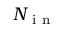Convert formula to latex. <formula><loc_0><loc_0><loc_500><loc_500>N _ { i n }</formula> 